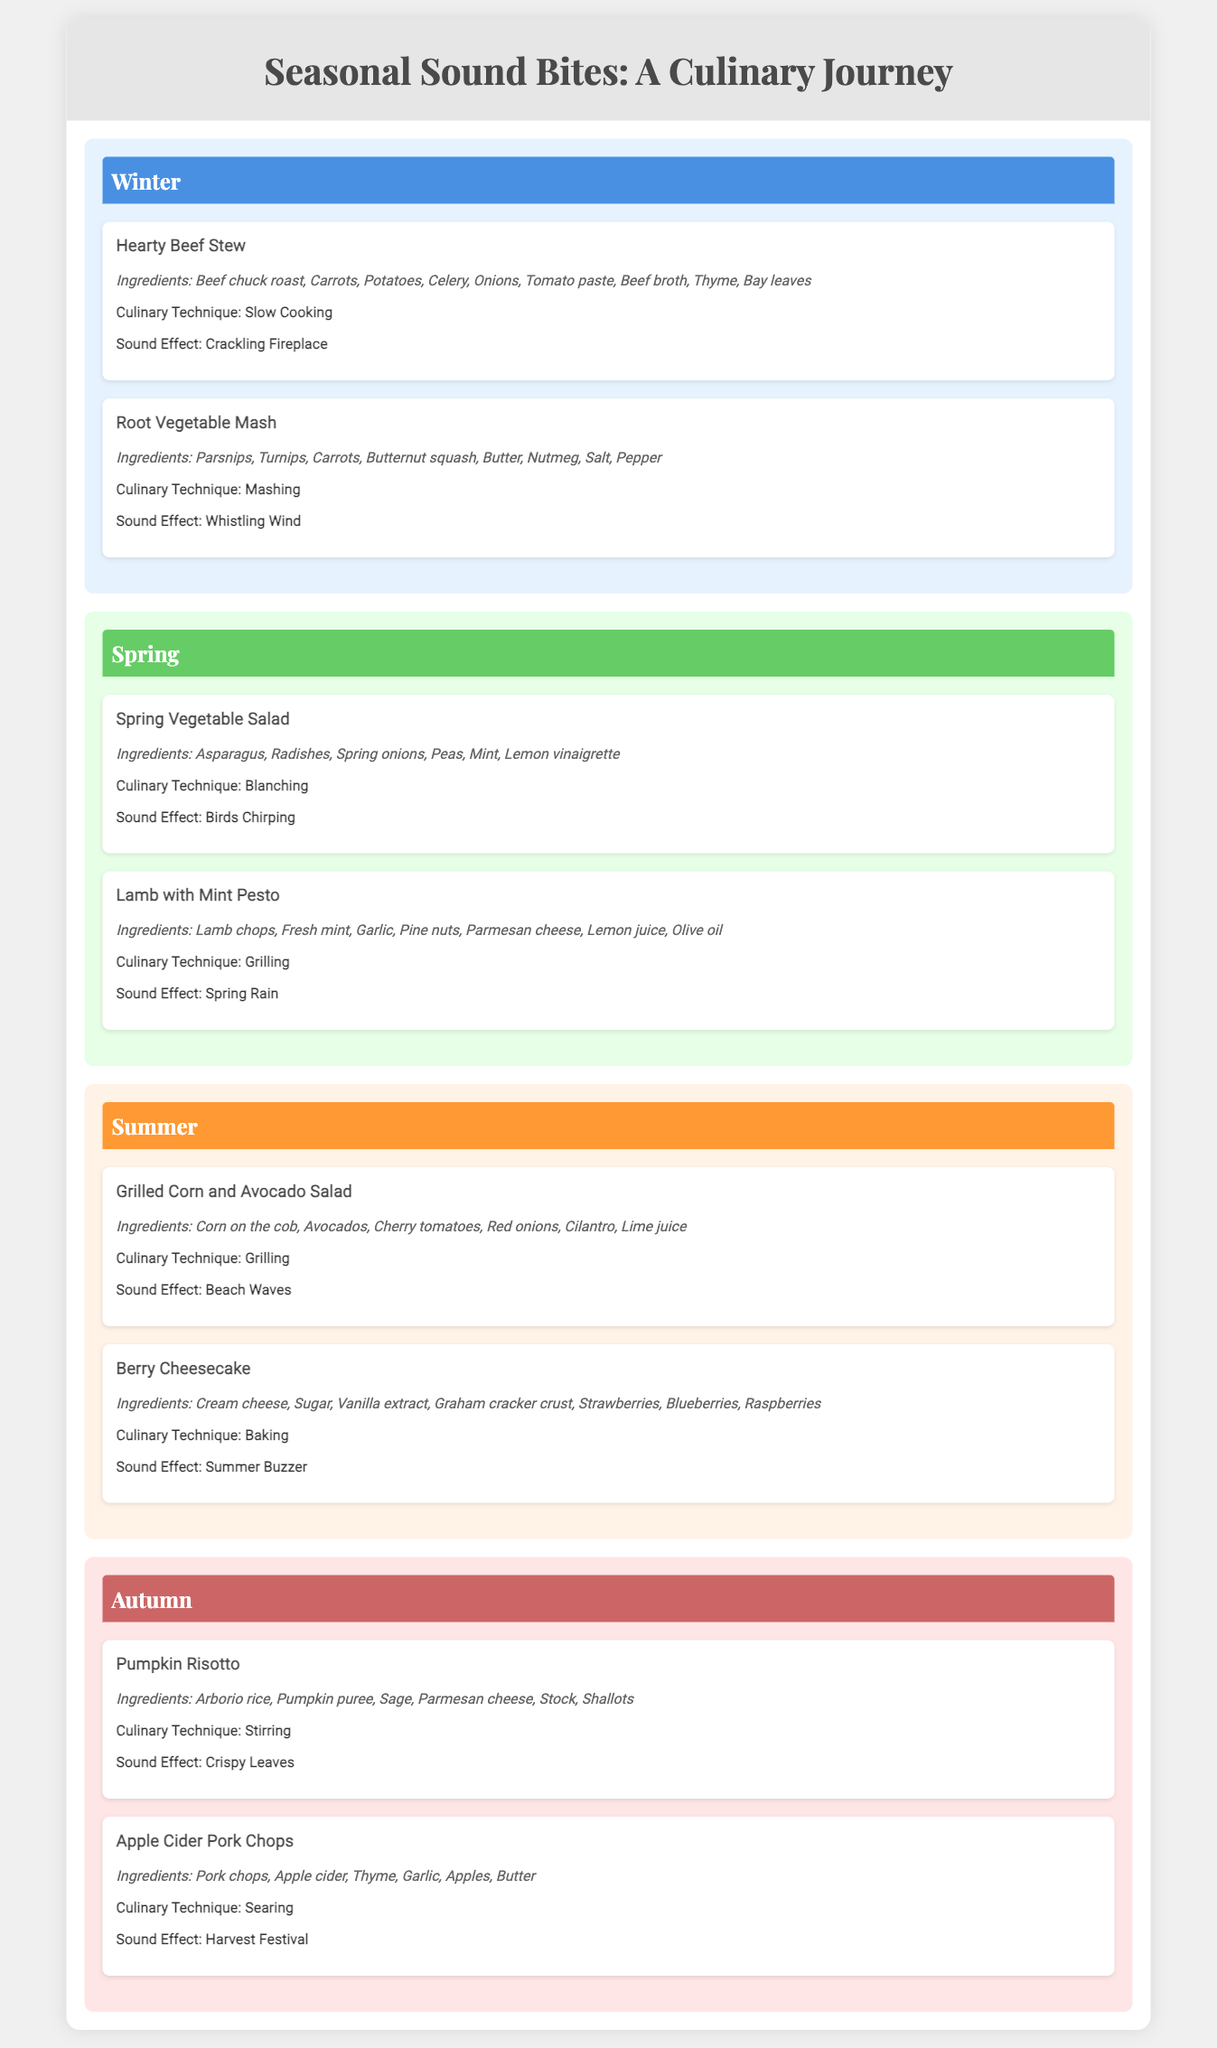What is the title of the document? The title is displayed prominently at the top of the document and is "Seasonal Sound Bites: A Culinary Journey".
Answer: Seasonal Sound Bites: A Culinary Journey How many meals are listed for winter? The document contains two meals listed under the winter section, namely Hearty Beef Stew and Root Vegetable Mash.
Answer: 2 What is the sound effect associated with the Spring Vegetable Salad? The sound effect is mentioned in the meal details for Spring Vegetable Salad, which is "Birds Chirping".
Answer: Birds Chirping What culinary technique is used for the Grilled Corn and Avocado Salad? The meal details state that the culinary technique for Grilled Corn and Avocado Salad is "Grilling".
Answer: Grilling Which season features the meal "Pumpkin Risotto"? The document categorizes Pumpkin Risotto under the autumn season.
Answer: Autumn What ingredient is common in both the Hearty Beef Stew and the Apple Cider Pork Chops? Both meals list "Thyme" as a common ingredient among their ingredients.
Answer: Thyme What sound effect is linked with the Berry Cheesecake? The sound effect related to Berry Cheesecake is stated in its meal section as "Summer Buzzer".
Answer: Summer Buzzer What is the main ingredient in Lamb with Mint Pesto? The primary ingredient identified for Lamb with Mint Pesto is "Lamb chops".
Answer: Lamb chops What is the technique used for the preparation of the Root Vegetable Mash? The document specifies that the technique for Root Vegetable Mash is "Mashing".
Answer: Mashing 